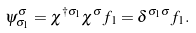<formula> <loc_0><loc_0><loc_500><loc_500>\psi _ { \sigma _ { 1 } } ^ { \sigma } = \chi ^ { \dagger \sigma _ { 1 } } \chi ^ { \sigma } f _ { 1 } = \delta ^ { \sigma _ { 1 } \sigma } f _ { 1 } .</formula> 